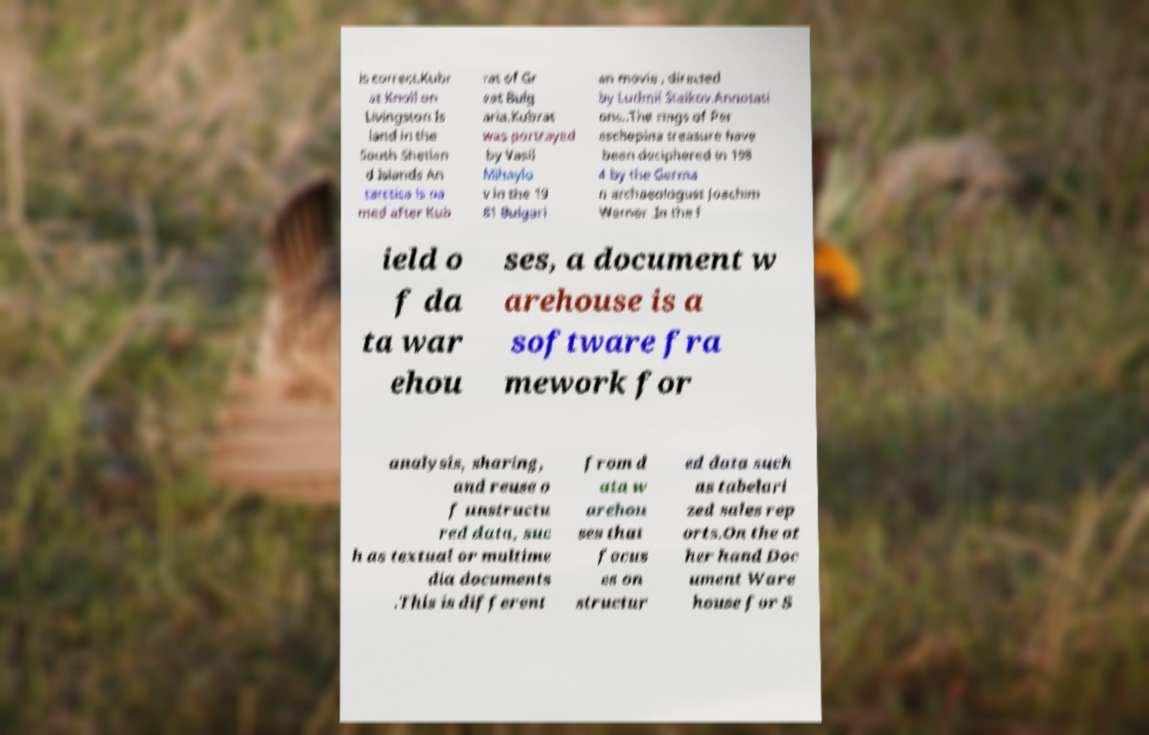Please read and relay the text visible in this image. What does it say? is correct.Kubr at Knoll on Livingston Is land in the South Shetlan d Islands An tarctica is na med after Kub rat of Gr eat Bulg aria.Kubrat was portrayed by Vasil Mihaylo v in the 19 81 Bulgari an movie , directed by Ludmil Staikov.Annotati ons..The rings of Per eschepina treasure have been deciphered in 198 4 by the Germa n archaeologust Joachim Werner .In the f ield o f da ta war ehou ses, a document w arehouse is a software fra mework for analysis, sharing, and reuse o f unstructu red data, suc h as textual or multime dia documents .This is different from d ata w arehou ses that focus es on structur ed data such as tabelari zed sales rep orts.On the ot her hand Doc ument Ware house for S 